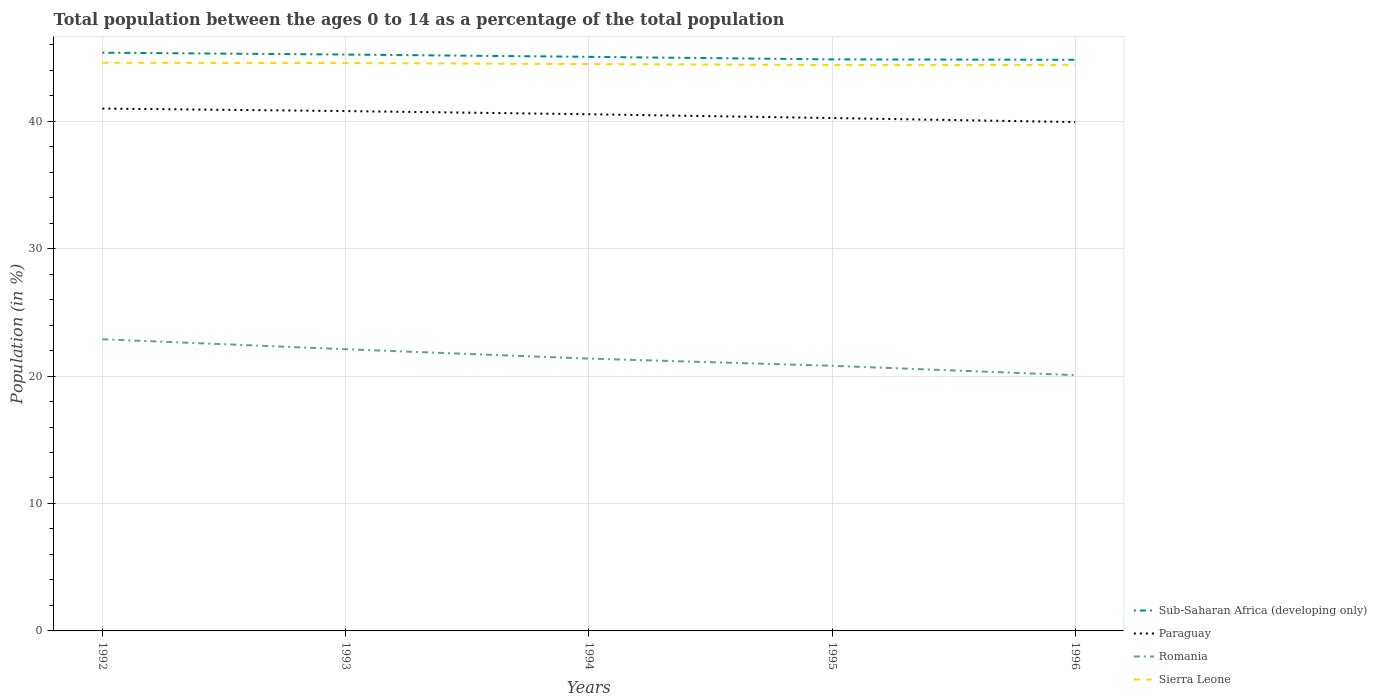Does the line corresponding to Sub-Saharan Africa (developing only) intersect with the line corresponding to Paraguay?
Keep it short and to the point. No. Across all years, what is the maximum percentage of the population ages 0 to 14 in Romania?
Your answer should be very brief. 20.07. What is the total percentage of the population ages 0 to 14 in Sierra Leone in the graph?
Give a very brief answer. 0.02. What is the difference between the highest and the second highest percentage of the population ages 0 to 14 in Sub-Saharan Africa (developing only)?
Make the answer very short. 0.56. What is the difference between the highest and the lowest percentage of the population ages 0 to 14 in Romania?
Keep it short and to the point. 2. Are the values on the major ticks of Y-axis written in scientific E-notation?
Give a very brief answer. No. Does the graph contain any zero values?
Your answer should be very brief. No. Does the graph contain grids?
Make the answer very short. Yes. Where does the legend appear in the graph?
Offer a very short reply. Bottom right. How many legend labels are there?
Keep it short and to the point. 4. What is the title of the graph?
Your answer should be compact. Total population between the ages 0 to 14 as a percentage of the total population. Does "Other small states" appear as one of the legend labels in the graph?
Give a very brief answer. No. What is the label or title of the Y-axis?
Make the answer very short. Population (in %). What is the Population (in %) in Sub-Saharan Africa (developing only) in 1992?
Keep it short and to the point. 45.37. What is the Population (in %) in Paraguay in 1992?
Offer a terse response. 40.99. What is the Population (in %) in Romania in 1992?
Provide a succinct answer. 22.89. What is the Population (in %) in Sierra Leone in 1992?
Your answer should be compact. 44.58. What is the Population (in %) of Sub-Saharan Africa (developing only) in 1993?
Offer a terse response. 45.22. What is the Population (in %) in Paraguay in 1993?
Give a very brief answer. 40.79. What is the Population (in %) of Romania in 1993?
Your response must be concise. 22.1. What is the Population (in %) in Sierra Leone in 1993?
Give a very brief answer. 44.56. What is the Population (in %) in Sub-Saharan Africa (developing only) in 1994?
Make the answer very short. 45.05. What is the Population (in %) of Paraguay in 1994?
Provide a succinct answer. 40.54. What is the Population (in %) of Romania in 1994?
Your response must be concise. 21.37. What is the Population (in %) of Sierra Leone in 1994?
Provide a short and direct response. 44.48. What is the Population (in %) in Sub-Saharan Africa (developing only) in 1995?
Your response must be concise. 44.84. What is the Population (in %) in Paraguay in 1995?
Your answer should be compact. 40.24. What is the Population (in %) of Romania in 1995?
Make the answer very short. 20.8. What is the Population (in %) of Sierra Leone in 1995?
Provide a short and direct response. 44.4. What is the Population (in %) in Sub-Saharan Africa (developing only) in 1996?
Give a very brief answer. 44.81. What is the Population (in %) of Paraguay in 1996?
Keep it short and to the point. 39.93. What is the Population (in %) in Romania in 1996?
Keep it short and to the point. 20.07. What is the Population (in %) in Sierra Leone in 1996?
Ensure brevity in your answer.  44.42. Across all years, what is the maximum Population (in %) in Sub-Saharan Africa (developing only)?
Your response must be concise. 45.37. Across all years, what is the maximum Population (in %) of Paraguay?
Provide a short and direct response. 40.99. Across all years, what is the maximum Population (in %) in Romania?
Offer a very short reply. 22.89. Across all years, what is the maximum Population (in %) in Sierra Leone?
Keep it short and to the point. 44.58. Across all years, what is the minimum Population (in %) of Sub-Saharan Africa (developing only)?
Give a very brief answer. 44.81. Across all years, what is the minimum Population (in %) of Paraguay?
Your response must be concise. 39.93. Across all years, what is the minimum Population (in %) of Romania?
Your answer should be very brief. 20.07. Across all years, what is the minimum Population (in %) in Sierra Leone?
Make the answer very short. 44.4. What is the total Population (in %) of Sub-Saharan Africa (developing only) in the graph?
Provide a succinct answer. 225.3. What is the total Population (in %) in Paraguay in the graph?
Keep it short and to the point. 202.49. What is the total Population (in %) of Romania in the graph?
Make the answer very short. 107.23. What is the total Population (in %) in Sierra Leone in the graph?
Give a very brief answer. 222.43. What is the difference between the Population (in %) in Sub-Saharan Africa (developing only) in 1992 and that in 1993?
Provide a short and direct response. 0.15. What is the difference between the Population (in %) in Paraguay in 1992 and that in 1993?
Your response must be concise. 0.2. What is the difference between the Population (in %) in Romania in 1992 and that in 1993?
Make the answer very short. 0.78. What is the difference between the Population (in %) in Sierra Leone in 1992 and that in 1993?
Keep it short and to the point. 0.02. What is the difference between the Population (in %) of Sub-Saharan Africa (developing only) in 1992 and that in 1994?
Your response must be concise. 0.32. What is the difference between the Population (in %) in Paraguay in 1992 and that in 1994?
Offer a terse response. 0.45. What is the difference between the Population (in %) of Romania in 1992 and that in 1994?
Make the answer very short. 1.52. What is the difference between the Population (in %) in Sierra Leone in 1992 and that in 1994?
Offer a terse response. 0.1. What is the difference between the Population (in %) of Sub-Saharan Africa (developing only) in 1992 and that in 1995?
Keep it short and to the point. 0.52. What is the difference between the Population (in %) of Paraguay in 1992 and that in 1995?
Your response must be concise. 0.74. What is the difference between the Population (in %) of Romania in 1992 and that in 1995?
Provide a succinct answer. 2.08. What is the difference between the Population (in %) of Sierra Leone in 1992 and that in 1995?
Keep it short and to the point. 0.17. What is the difference between the Population (in %) in Sub-Saharan Africa (developing only) in 1992 and that in 1996?
Keep it short and to the point. 0.56. What is the difference between the Population (in %) in Paraguay in 1992 and that in 1996?
Provide a succinct answer. 1.06. What is the difference between the Population (in %) of Romania in 1992 and that in 1996?
Your answer should be compact. 2.82. What is the difference between the Population (in %) in Sierra Leone in 1992 and that in 1996?
Your answer should be very brief. 0.16. What is the difference between the Population (in %) in Sub-Saharan Africa (developing only) in 1993 and that in 1994?
Give a very brief answer. 0.18. What is the difference between the Population (in %) in Paraguay in 1993 and that in 1994?
Make the answer very short. 0.25. What is the difference between the Population (in %) of Romania in 1993 and that in 1994?
Your answer should be very brief. 0.74. What is the difference between the Population (in %) of Sierra Leone in 1993 and that in 1994?
Ensure brevity in your answer.  0.08. What is the difference between the Population (in %) of Sub-Saharan Africa (developing only) in 1993 and that in 1995?
Offer a terse response. 0.38. What is the difference between the Population (in %) in Paraguay in 1993 and that in 1995?
Provide a succinct answer. 0.55. What is the difference between the Population (in %) in Romania in 1993 and that in 1995?
Offer a terse response. 1.3. What is the difference between the Population (in %) of Sierra Leone in 1993 and that in 1995?
Provide a succinct answer. 0.16. What is the difference between the Population (in %) in Sub-Saharan Africa (developing only) in 1993 and that in 1996?
Your answer should be very brief. 0.41. What is the difference between the Population (in %) in Paraguay in 1993 and that in 1996?
Your answer should be compact. 0.86. What is the difference between the Population (in %) of Romania in 1993 and that in 1996?
Provide a short and direct response. 2.03. What is the difference between the Population (in %) of Sierra Leone in 1993 and that in 1996?
Provide a short and direct response. 0.14. What is the difference between the Population (in %) of Sub-Saharan Africa (developing only) in 1994 and that in 1995?
Your answer should be compact. 0.2. What is the difference between the Population (in %) in Paraguay in 1994 and that in 1995?
Provide a succinct answer. 0.3. What is the difference between the Population (in %) in Romania in 1994 and that in 1995?
Your response must be concise. 0.56. What is the difference between the Population (in %) in Sierra Leone in 1994 and that in 1995?
Keep it short and to the point. 0.08. What is the difference between the Population (in %) of Sub-Saharan Africa (developing only) in 1994 and that in 1996?
Offer a terse response. 0.23. What is the difference between the Population (in %) of Paraguay in 1994 and that in 1996?
Ensure brevity in your answer.  0.61. What is the difference between the Population (in %) in Romania in 1994 and that in 1996?
Your answer should be compact. 1.3. What is the difference between the Population (in %) of Sierra Leone in 1994 and that in 1996?
Provide a succinct answer. 0.06. What is the difference between the Population (in %) of Sub-Saharan Africa (developing only) in 1995 and that in 1996?
Offer a terse response. 0.03. What is the difference between the Population (in %) of Paraguay in 1995 and that in 1996?
Make the answer very short. 0.31. What is the difference between the Population (in %) in Romania in 1995 and that in 1996?
Provide a short and direct response. 0.74. What is the difference between the Population (in %) of Sierra Leone in 1995 and that in 1996?
Offer a terse response. -0.01. What is the difference between the Population (in %) in Sub-Saharan Africa (developing only) in 1992 and the Population (in %) in Paraguay in 1993?
Make the answer very short. 4.58. What is the difference between the Population (in %) in Sub-Saharan Africa (developing only) in 1992 and the Population (in %) in Romania in 1993?
Give a very brief answer. 23.27. What is the difference between the Population (in %) in Sub-Saharan Africa (developing only) in 1992 and the Population (in %) in Sierra Leone in 1993?
Your response must be concise. 0.81. What is the difference between the Population (in %) in Paraguay in 1992 and the Population (in %) in Romania in 1993?
Provide a short and direct response. 18.88. What is the difference between the Population (in %) in Paraguay in 1992 and the Population (in %) in Sierra Leone in 1993?
Your response must be concise. -3.57. What is the difference between the Population (in %) of Romania in 1992 and the Population (in %) of Sierra Leone in 1993?
Offer a very short reply. -21.67. What is the difference between the Population (in %) of Sub-Saharan Africa (developing only) in 1992 and the Population (in %) of Paraguay in 1994?
Give a very brief answer. 4.83. What is the difference between the Population (in %) in Sub-Saharan Africa (developing only) in 1992 and the Population (in %) in Romania in 1994?
Make the answer very short. 24. What is the difference between the Population (in %) in Sub-Saharan Africa (developing only) in 1992 and the Population (in %) in Sierra Leone in 1994?
Keep it short and to the point. 0.89. What is the difference between the Population (in %) in Paraguay in 1992 and the Population (in %) in Romania in 1994?
Provide a succinct answer. 19.62. What is the difference between the Population (in %) in Paraguay in 1992 and the Population (in %) in Sierra Leone in 1994?
Provide a succinct answer. -3.49. What is the difference between the Population (in %) in Romania in 1992 and the Population (in %) in Sierra Leone in 1994?
Your response must be concise. -21.59. What is the difference between the Population (in %) in Sub-Saharan Africa (developing only) in 1992 and the Population (in %) in Paraguay in 1995?
Give a very brief answer. 5.13. What is the difference between the Population (in %) in Sub-Saharan Africa (developing only) in 1992 and the Population (in %) in Romania in 1995?
Provide a succinct answer. 24.57. What is the difference between the Population (in %) in Paraguay in 1992 and the Population (in %) in Romania in 1995?
Offer a terse response. 20.18. What is the difference between the Population (in %) in Paraguay in 1992 and the Population (in %) in Sierra Leone in 1995?
Offer a very short reply. -3.42. What is the difference between the Population (in %) in Romania in 1992 and the Population (in %) in Sierra Leone in 1995?
Make the answer very short. -21.52. What is the difference between the Population (in %) in Sub-Saharan Africa (developing only) in 1992 and the Population (in %) in Paraguay in 1996?
Your answer should be very brief. 5.44. What is the difference between the Population (in %) in Sub-Saharan Africa (developing only) in 1992 and the Population (in %) in Romania in 1996?
Make the answer very short. 25.3. What is the difference between the Population (in %) in Sub-Saharan Africa (developing only) in 1992 and the Population (in %) in Sierra Leone in 1996?
Your answer should be compact. 0.95. What is the difference between the Population (in %) of Paraguay in 1992 and the Population (in %) of Romania in 1996?
Give a very brief answer. 20.92. What is the difference between the Population (in %) of Paraguay in 1992 and the Population (in %) of Sierra Leone in 1996?
Give a very brief answer. -3.43. What is the difference between the Population (in %) of Romania in 1992 and the Population (in %) of Sierra Leone in 1996?
Provide a succinct answer. -21.53. What is the difference between the Population (in %) in Sub-Saharan Africa (developing only) in 1993 and the Population (in %) in Paraguay in 1994?
Your response must be concise. 4.68. What is the difference between the Population (in %) in Sub-Saharan Africa (developing only) in 1993 and the Population (in %) in Romania in 1994?
Give a very brief answer. 23.86. What is the difference between the Population (in %) of Sub-Saharan Africa (developing only) in 1993 and the Population (in %) of Sierra Leone in 1994?
Ensure brevity in your answer.  0.75. What is the difference between the Population (in %) in Paraguay in 1993 and the Population (in %) in Romania in 1994?
Provide a short and direct response. 19.42. What is the difference between the Population (in %) in Paraguay in 1993 and the Population (in %) in Sierra Leone in 1994?
Your answer should be compact. -3.69. What is the difference between the Population (in %) of Romania in 1993 and the Population (in %) of Sierra Leone in 1994?
Your answer should be very brief. -22.38. What is the difference between the Population (in %) of Sub-Saharan Africa (developing only) in 1993 and the Population (in %) of Paraguay in 1995?
Your answer should be very brief. 4.98. What is the difference between the Population (in %) in Sub-Saharan Africa (developing only) in 1993 and the Population (in %) in Romania in 1995?
Ensure brevity in your answer.  24.42. What is the difference between the Population (in %) in Sub-Saharan Africa (developing only) in 1993 and the Population (in %) in Sierra Leone in 1995?
Offer a terse response. 0.82. What is the difference between the Population (in %) of Paraguay in 1993 and the Population (in %) of Romania in 1995?
Your answer should be very brief. 19.98. What is the difference between the Population (in %) in Paraguay in 1993 and the Population (in %) in Sierra Leone in 1995?
Make the answer very short. -3.61. What is the difference between the Population (in %) of Romania in 1993 and the Population (in %) of Sierra Leone in 1995?
Make the answer very short. -22.3. What is the difference between the Population (in %) in Sub-Saharan Africa (developing only) in 1993 and the Population (in %) in Paraguay in 1996?
Your answer should be very brief. 5.3. What is the difference between the Population (in %) of Sub-Saharan Africa (developing only) in 1993 and the Population (in %) of Romania in 1996?
Your answer should be compact. 25.16. What is the difference between the Population (in %) in Sub-Saharan Africa (developing only) in 1993 and the Population (in %) in Sierra Leone in 1996?
Offer a terse response. 0.81. What is the difference between the Population (in %) in Paraguay in 1993 and the Population (in %) in Romania in 1996?
Offer a terse response. 20.72. What is the difference between the Population (in %) in Paraguay in 1993 and the Population (in %) in Sierra Leone in 1996?
Your answer should be very brief. -3.63. What is the difference between the Population (in %) of Romania in 1993 and the Population (in %) of Sierra Leone in 1996?
Your response must be concise. -22.31. What is the difference between the Population (in %) in Sub-Saharan Africa (developing only) in 1994 and the Population (in %) in Paraguay in 1995?
Give a very brief answer. 4.8. What is the difference between the Population (in %) in Sub-Saharan Africa (developing only) in 1994 and the Population (in %) in Romania in 1995?
Your answer should be very brief. 24.24. What is the difference between the Population (in %) of Sub-Saharan Africa (developing only) in 1994 and the Population (in %) of Sierra Leone in 1995?
Offer a terse response. 0.64. What is the difference between the Population (in %) in Paraguay in 1994 and the Population (in %) in Romania in 1995?
Make the answer very short. 19.74. What is the difference between the Population (in %) of Paraguay in 1994 and the Population (in %) of Sierra Leone in 1995?
Your response must be concise. -3.86. What is the difference between the Population (in %) in Romania in 1994 and the Population (in %) in Sierra Leone in 1995?
Offer a very short reply. -23.03. What is the difference between the Population (in %) in Sub-Saharan Africa (developing only) in 1994 and the Population (in %) in Paraguay in 1996?
Offer a very short reply. 5.12. What is the difference between the Population (in %) of Sub-Saharan Africa (developing only) in 1994 and the Population (in %) of Romania in 1996?
Give a very brief answer. 24.98. What is the difference between the Population (in %) in Sub-Saharan Africa (developing only) in 1994 and the Population (in %) in Sierra Leone in 1996?
Provide a short and direct response. 0.63. What is the difference between the Population (in %) in Paraguay in 1994 and the Population (in %) in Romania in 1996?
Ensure brevity in your answer.  20.47. What is the difference between the Population (in %) of Paraguay in 1994 and the Population (in %) of Sierra Leone in 1996?
Your answer should be very brief. -3.87. What is the difference between the Population (in %) of Romania in 1994 and the Population (in %) of Sierra Leone in 1996?
Your response must be concise. -23.05. What is the difference between the Population (in %) in Sub-Saharan Africa (developing only) in 1995 and the Population (in %) in Paraguay in 1996?
Give a very brief answer. 4.92. What is the difference between the Population (in %) in Sub-Saharan Africa (developing only) in 1995 and the Population (in %) in Romania in 1996?
Your answer should be very brief. 24.78. What is the difference between the Population (in %) in Sub-Saharan Africa (developing only) in 1995 and the Population (in %) in Sierra Leone in 1996?
Offer a terse response. 0.43. What is the difference between the Population (in %) of Paraguay in 1995 and the Population (in %) of Romania in 1996?
Offer a terse response. 20.17. What is the difference between the Population (in %) in Paraguay in 1995 and the Population (in %) in Sierra Leone in 1996?
Provide a succinct answer. -4.17. What is the difference between the Population (in %) in Romania in 1995 and the Population (in %) in Sierra Leone in 1996?
Provide a short and direct response. -23.61. What is the average Population (in %) of Sub-Saharan Africa (developing only) per year?
Your answer should be very brief. 45.06. What is the average Population (in %) in Paraguay per year?
Ensure brevity in your answer.  40.5. What is the average Population (in %) of Romania per year?
Your answer should be compact. 21.45. What is the average Population (in %) in Sierra Leone per year?
Your response must be concise. 44.49. In the year 1992, what is the difference between the Population (in %) of Sub-Saharan Africa (developing only) and Population (in %) of Paraguay?
Your answer should be very brief. 4.38. In the year 1992, what is the difference between the Population (in %) in Sub-Saharan Africa (developing only) and Population (in %) in Romania?
Your answer should be very brief. 22.48. In the year 1992, what is the difference between the Population (in %) of Sub-Saharan Africa (developing only) and Population (in %) of Sierra Leone?
Your answer should be compact. 0.79. In the year 1992, what is the difference between the Population (in %) of Paraguay and Population (in %) of Romania?
Provide a short and direct response. 18.1. In the year 1992, what is the difference between the Population (in %) of Paraguay and Population (in %) of Sierra Leone?
Provide a succinct answer. -3.59. In the year 1992, what is the difference between the Population (in %) of Romania and Population (in %) of Sierra Leone?
Your answer should be compact. -21.69. In the year 1993, what is the difference between the Population (in %) in Sub-Saharan Africa (developing only) and Population (in %) in Paraguay?
Keep it short and to the point. 4.43. In the year 1993, what is the difference between the Population (in %) of Sub-Saharan Africa (developing only) and Population (in %) of Romania?
Your answer should be very brief. 23.12. In the year 1993, what is the difference between the Population (in %) of Sub-Saharan Africa (developing only) and Population (in %) of Sierra Leone?
Your response must be concise. 0.66. In the year 1993, what is the difference between the Population (in %) of Paraguay and Population (in %) of Romania?
Your answer should be compact. 18.69. In the year 1993, what is the difference between the Population (in %) in Paraguay and Population (in %) in Sierra Leone?
Keep it short and to the point. -3.77. In the year 1993, what is the difference between the Population (in %) in Romania and Population (in %) in Sierra Leone?
Provide a succinct answer. -22.46. In the year 1994, what is the difference between the Population (in %) of Sub-Saharan Africa (developing only) and Population (in %) of Paraguay?
Offer a terse response. 4.5. In the year 1994, what is the difference between the Population (in %) in Sub-Saharan Africa (developing only) and Population (in %) in Romania?
Offer a terse response. 23.68. In the year 1994, what is the difference between the Population (in %) in Sub-Saharan Africa (developing only) and Population (in %) in Sierra Leone?
Your response must be concise. 0.57. In the year 1994, what is the difference between the Population (in %) in Paraguay and Population (in %) in Romania?
Provide a short and direct response. 19.17. In the year 1994, what is the difference between the Population (in %) of Paraguay and Population (in %) of Sierra Leone?
Ensure brevity in your answer.  -3.94. In the year 1994, what is the difference between the Population (in %) of Romania and Population (in %) of Sierra Leone?
Your answer should be very brief. -23.11. In the year 1995, what is the difference between the Population (in %) in Sub-Saharan Africa (developing only) and Population (in %) in Paraguay?
Make the answer very short. 4.6. In the year 1995, what is the difference between the Population (in %) in Sub-Saharan Africa (developing only) and Population (in %) in Romania?
Offer a terse response. 24.04. In the year 1995, what is the difference between the Population (in %) of Sub-Saharan Africa (developing only) and Population (in %) of Sierra Leone?
Your answer should be very brief. 0.44. In the year 1995, what is the difference between the Population (in %) in Paraguay and Population (in %) in Romania?
Ensure brevity in your answer.  19.44. In the year 1995, what is the difference between the Population (in %) of Paraguay and Population (in %) of Sierra Leone?
Your answer should be compact. -4.16. In the year 1995, what is the difference between the Population (in %) of Romania and Population (in %) of Sierra Leone?
Provide a succinct answer. -23.6. In the year 1996, what is the difference between the Population (in %) of Sub-Saharan Africa (developing only) and Population (in %) of Paraguay?
Provide a short and direct response. 4.89. In the year 1996, what is the difference between the Population (in %) in Sub-Saharan Africa (developing only) and Population (in %) in Romania?
Your answer should be very brief. 24.74. In the year 1996, what is the difference between the Population (in %) in Sub-Saharan Africa (developing only) and Population (in %) in Sierra Leone?
Your answer should be compact. 0.4. In the year 1996, what is the difference between the Population (in %) of Paraguay and Population (in %) of Romania?
Provide a short and direct response. 19.86. In the year 1996, what is the difference between the Population (in %) in Paraguay and Population (in %) in Sierra Leone?
Provide a short and direct response. -4.49. In the year 1996, what is the difference between the Population (in %) in Romania and Population (in %) in Sierra Leone?
Provide a succinct answer. -24.35. What is the ratio of the Population (in %) of Paraguay in 1992 to that in 1993?
Your answer should be compact. 1. What is the ratio of the Population (in %) of Romania in 1992 to that in 1993?
Ensure brevity in your answer.  1.04. What is the ratio of the Population (in %) in Sierra Leone in 1992 to that in 1993?
Your answer should be compact. 1. What is the ratio of the Population (in %) of Romania in 1992 to that in 1994?
Give a very brief answer. 1.07. What is the ratio of the Population (in %) of Sub-Saharan Africa (developing only) in 1992 to that in 1995?
Offer a terse response. 1.01. What is the ratio of the Population (in %) of Paraguay in 1992 to that in 1995?
Give a very brief answer. 1.02. What is the ratio of the Population (in %) of Romania in 1992 to that in 1995?
Offer a terse response. 1.1. What is the ratio of the Population (in %) of Sierra Leone in 1992 to that in 1995?
Ensure brevity in your answer.  1. What is the ratio of the Population (in %) of Sub-Saharan Africa (developing only) in 1992 to that in 1996?
Provide a succinct answer. 1.01. What is the ratio of the Population (in %) in Paraguay in 1992 to that in 1996?
Your response must be concise. 1.03. What is the ratio of the Population (in %) in Romania in 1992 to that in 1996?
Your response must be concise. 1.14. What is the ratio of the Population (in %) in Sierra Leone in 1992 to that in 1996?
Give a very brief answer. 1. What is the ratio of the Population (in %) of Sub-Saharan Africa (developing only) in 1993 to that in 1994?
Your answer should be compact. 1. What is the ratio of the Population (in %) in Romania in 1993 to that in 1994?
Your answer should be compact. 1.03. What is the ratio of the Population (in %) of Sierra Leone in 1993 to that in 1994?
Give a very brief answer. 1. What is the ratio of the Population (in %) of Sub-Saharan Africa (developing only) in 1993 to that in 1995?
Keep it short and to the point. 1.01. What is the ratio of the Population (in %) of Paraguay in 1993 to that in 1995?
Your answer should be very brief. 1.01. What is the ratio of the Population (in %) of Romania in 1993 to that in 1995?
Offer a terse response. 1.06. What is the ratio of the Population (in %) of Sub-Saharan Africa (developing only) in 1993 to that in 1996?
Offer a very short reply. 1.01. What is the ratio of the Population (in %) in Paraguay in 1993 to that in 1996?
Offer a very short reply. 1.02. What is the ratio of the Population (in %) in Romania in 1993 to that in 1996?
Keep it short and to the point. 1.1. What is the ratio of the Population (in %) in Sub-Saharan Africa (developing only) in 1994 to that in 1995?
Make the answer very short. 1. What is the ratio of the Population (in %) in Paraguay in 1994 to that in 1995?
Offer a very short reply. 1.01. What is the ratio of the Population (in %) in Romania in 1994 to that in 1995?
Ensure brevity in your answer.  1.03. What is the ratio of the Population (in %) of Sierra Leone in 1994 to that in 1995?
Make the answer very short. 1. What is the ratio of the Population (in %) of Paraguay in 1994 to that in 1996?
Keep it short and to the point. 1.02. What is the ratio of the Population (in %) in Romania in 1994 to that in 1996?
Your answer should be compact. 1.06. What is the ratio of the Population (in %) of Paraguay in 1995 to that in 1996?
Give a very brief answer. 1.01. What is the ratio of the Population (in %) in Romania in 1995 to that in 1996?
Keep it short and to the point. 1.04. What is the difference between the highest and the second highest Population (in %) in Sub-Saharan Africa (developing only)?
Make the answer very short. 0.15. What is the difference between the highest and the second highest Population (in %) of Paraguay?
Your answer should be very brief. 0.2. What is the difference between the highest and the second highest Population (in %) in Romania?
Provide a short and direct response. 0.78. What is the difference between the highest and the second highest Population (in %) in Sierra Leone?
Provide a succinct answer. 0.02. What is the difference between the highest and the lowest Population (in %) of Sub-Saharan Africa (developing only)?
Your response must be concise. 0.56. What is the difference between the highest and the lowest Population (in %) of Paraguay?
Ensure brevity in your answer.  1.06. What is the difference between the highest and the lowest Population (in %) in Romania?
Offer a terse response. 2.82. What is the difference between the highest and the lowest Population (in %) of Sierra Leone?
Offer a terse response. 0.17. 